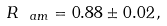<formula> <loc_0><loc_0><loc_500><loc_500>R _ { \ a m } = 0 . 8 8 \pm 0 . 0 2 \, ,</formula> 